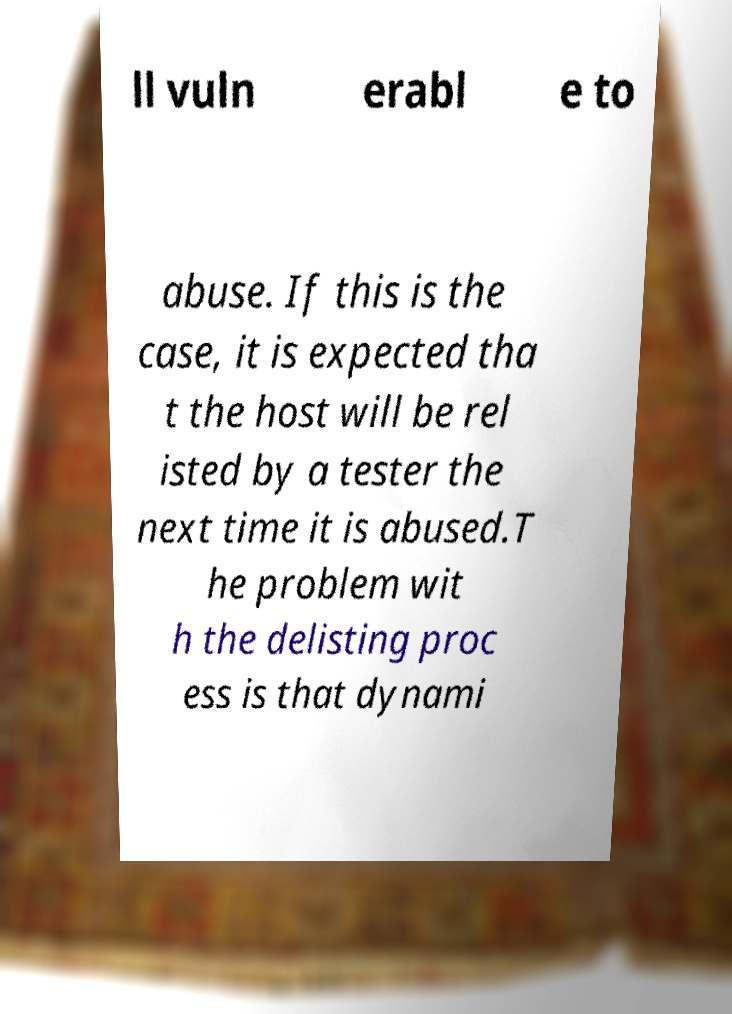Please read and relay the text visible in this image. What does it say? ll vuln erabl e to abuse. If this is the case, it is expected tha t the host will be rel isted by a tester the next time it is abused.T he problem wit h the delisting proc ess is that dynami 